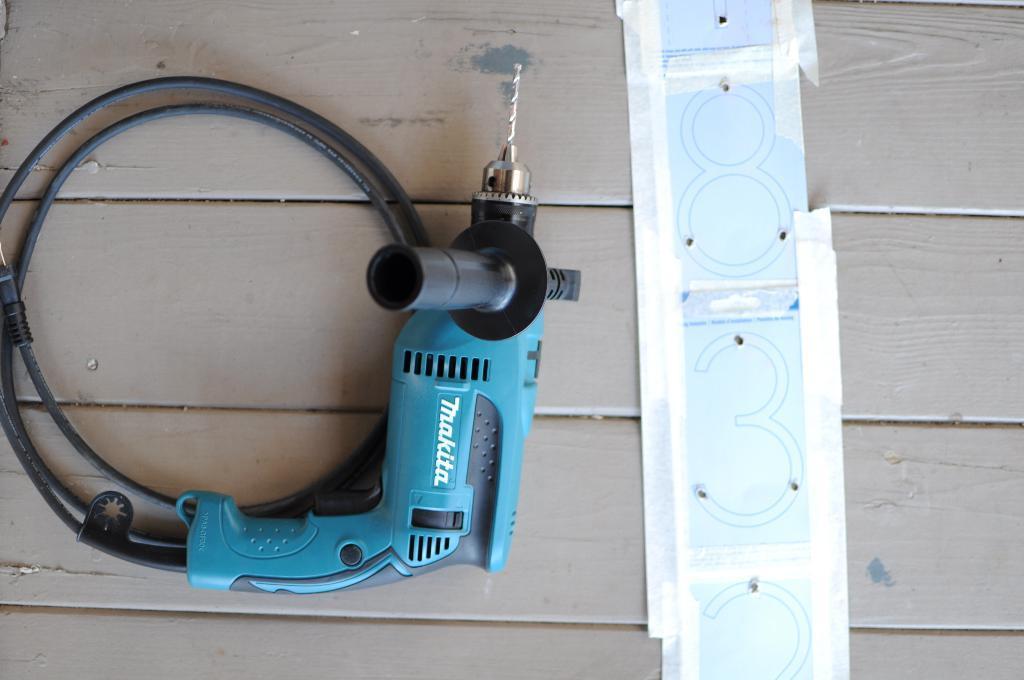Could you give a brief overview of what you see in this image? There is a drilling machine and an object on the wooden plank in the foreground area of the image. 